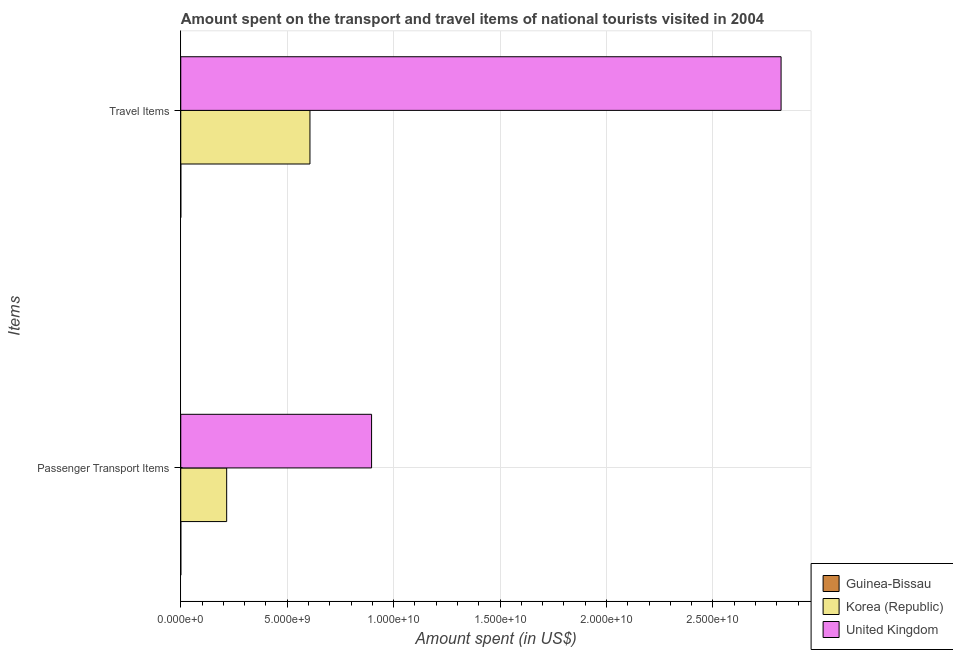How many bars are there on the 1st tick from the bottom?
Ensure brevity in your answer.  3. What is the label of the 2nd group of bars from the top?
Ensure brevity in your answer.  Passenger Transport Items. What is the amount spent in travel items in United Kingdom?
Ensure brevity in your answer.  2.82e+1. Across all countries, what is the maximum amount spent in travel items?
Provide a short and direct response. 2.82e+1. Across all countries, what is the minimum amount spent on passenger transport items?
Your answer should be compact. 1.20e+06. In which country was the amount spent in travel items minimum?
Your response must be concise. Guinea-Bissau. What is the total amount spent on passenger transport items in the graph?
Keep it short and to the point. 1.11e+1. What is the difference between the amount spent on passenger transport items in Korea (Republic) and that in Guinea-Bissau?
Offer a very short reply. 2.16e+09. What is the difference between the amount spent on passenger transport items in Guinea-Bissau and the amount spent in travel items in Korea (Republic)?
Offer a terse response. -6.07e+09. What is the average amount spent on passenger transport items per country?
Offer a very short reply. 3.71e+09. What is the difference between the amount spent in travel items and amount spent on passenger transport items in Korea (Republic)?
Provide a short and direct response. 3.91e+09. In how many countries, is the amount spent on passenger transport items greater than 14000000000 US$?
Ensure brevity in your answer.  0. What is the ratio of the amount spent in travel items in Korea (Republic) to that in United Kingdom?
Your response must be concise. 0.22. In how many countries, is the amount spent in travel items greater than the average amount spent in travel items taken over all countries?
Offer a terse response. 1. How many bars are there?
Your answer should be very brief. 6. What is the difference between two consecutive major ticks on the X-axis?
Your response must be concise. 5.00e+09. Are the values on the major ticks of X-axis written in scientific E-notation?
Offer a terse response. Yes. How many legend labels are there?
Offer a terse response. 3. What is the title of the graph?
Provide a succinct answer. Amount spent on the transport and travel items of national tourists visited in 2004. Does "Tajikistan" appear as one of the legend labels in the graph?
Provide a short and direct response. No. What is the label or title of the X-axis?
Provide a short and direct response. Amount spent (in US$). What is the label or title of the Y-axis?
Give a very brief answer. Items. What is the Amount spent (in US$) of Guinea-Bissau in Passenger Transport Items?
Your answer should be compact. 1.20e+06. What is the Amount spent (in US$) in Korea (Republic) in Passenger Transport Items?
Your answer should be very brief. 2.16e+09. What is the Amount spent (in US$) in United Kingdom in Passenger Transport Items?
Ensure brevity in your answer.  8.96e+09. What is the Amount spent (in US$) in Korea (Republic) in Travel Items?
Give a very brief answer. 6.07e+09. What is the Amount spent (in US$) in United Kingdom in Travel Items?
Provide a short and direct response. 2.82e+1. Across all Items, what is the maximum Amount spent (in US$) of Guinea-Bissau?
Your response must be concise. 1.20e+06. Across all Items, what is the maximum Amount spent (in US$) in Korea (Republic)?
Your response must be concise. 6.07e+09. Across all Items, what is the maximum Amount spent (in US$) of United Kingdom?
Your answer should be compact. 2.82e+1. Across all Items, what is the minimum Amount spent (in US$) in Korea (Republic)?
Your answer should be very brief. 2.16e+09. Across all Items, what is the minimum Amount spent (in US$) of United Kingdom?
Make the answer very short. 8.96e+09. What is the total Amount spent (in US$) in Guinea-Bissau in the graph?
Offer a very short reply. 2.20e+06. What is the total Amount spent (in US$) in Korea (Republic) in the graph?
Your answer should be compact. 8.23e+09. What is the total Amount spent (in US$) in United Kingdom in the graph?
Provide a short and direct response. 3.72e+1. What is the difference between the Amount spent (in US$) of Korea (Republic) in Passenger Transport Items and that in Travel Items?
Ensure brevity in your answer.  -3.91e+09. What is the difference between the Amount spent (in US$) of United Kingdom in Passenger Transport Items and that in Travel Items?
Your answer should be compact. -1.92e+1. What is the difference between the Amount spent (in US$) of Guinea-Bissau in Passenger Transport Items and the Amount spent (in US$) of Korea (Republic) in Travel Items?
Your response must be concise. -6.07e+09. What is the difference between the Amount spent (in US$) of Guinea-Bissau in Passenger Transport Items and the Amount spent (in US$) of United Kingdom in Travel Items?
Offer a very short reply. -2.82e+1. What is the difference between the Amount spent (in US$) in Korea (Republic) in Passenger Transport Items and the Amount spent (in US$) in United Kingdom in Travel Items?
Keep it short and to the point. -2.60e+1. What is the average Amount spent (in US$) of Guinea-Bissau per Items?
Your answer should be compact. 1.10e+06. What is the average Amount spent (in US$) in Korea (Republic) per Items?
Make the answer very short. 4.11e+09. What is the average Amount spent (in US$) in United Kingdom per Items?
Keep it short and to the point. 1.86e+1. What is the difference between the Amount spent (in US$) of Guinea-Bissau and Amount spent (in US$) of Korea (Republic) in Passenger Transport Items?
Provide a short and direct response. -2.16e+09. What is the difference between the Amount spent (in US$) of Guinea-Bissau and Amount spent (in US$) of United Kingdom in Passenger Transport Items?
Your answer should be compact. -8.96e+09. What is the difference between the Amount spent (in US$) of Korea (Republic) and Amount spent (in US$) of United Kingdom in Passenger Transport Items?
Ensure brevity in your answer.  -6.81e+09. What is the difference between the Amount spent (in US$) in Guinea-Bissau and Amount spent (in US$) in Korea (Republic) in Travel Items?
Keep it short and to the point. -6.07e+09. What is the difference between the Amount spent (in US$) of Guinea-Bissau and Amount spent (in US$) of United Kingdom in Travel Items?
Keep it short and to the point. -2.82e+1. What is the difference between the Amount spent (in US$) in Korea (Republic) and Amount spent (in US$) in United Kingdom in Travel Items?
Give a very brief answer. -2.21e+1. What is the ratio of the Amount spent (in US$) of Guinea-Bissau in Passenger Transport Items to that in Travel Items?
Provide a succinct answer. 1.2. What is the ratio of the Amount spent (in US$) of Korea (Republic) in Passenger Transport Items to that in Travel Items?
Keep it short and to the point. 0.36. What is the ratio of the Amount spent (in US$) in United Kingdom in Passenger Transport Items to that in Travel Items?
Keep it short and to the point. 0.32. What is the difference between the highest and the second highest Amount spent (in US$) in Guinea-Bissau?
Your answer should be very brief. 2.00e+05. What is the difference between the highest and the second highest Amount spent (in US$) in Korea (Republic)?
Make the answer very short. 3.91e+09. What is the difference between the highest and the second highest Amount spent (in US$) in United Kingdom?
Offer a very short reply. 1.92e+1. What is the difference between the highest and the lowest Amount spent (in US$) of Korea (Republic)?
Provide a short and direct response. 3.91e+09. What is the difference between the highest and the lowest Amount spent (in US$) in United Kingdom?
Your answer should be very brief. 1.92e+1. 